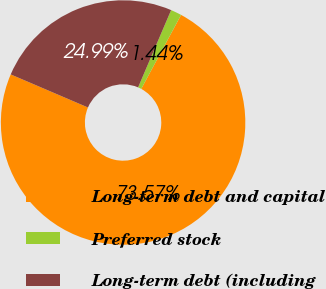<chart> <loc_0><loc_0><loc_500><loc_500><pie_chart><fcel>Long-term debt and capital<fcel>Preferred stock<fcel>Long-term debt (including<nl><fcel>73.57%<fcel>1.44%<fcel>24.99%<nl></chart> 